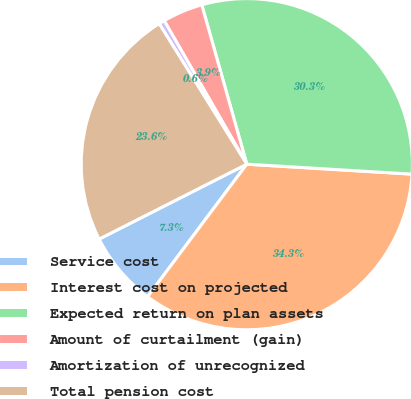Convert chart to OTSL. <chart><loc_0><loc_0><loc_500><loc_500><pie_chart><fcel>Service cost<fcel>Interest cost on projected<fcel>Expected return on plan assets<fcel>Amount of curtailment (gain)<fcel>Amortization of unrecognized<fcel>Total pension cost<nl><fcel>7.3%<fcel>34.27%<fcel>30.34%<fcel>3.93%<fcel>0.56%<fcel>23.6%<nl></chart> 